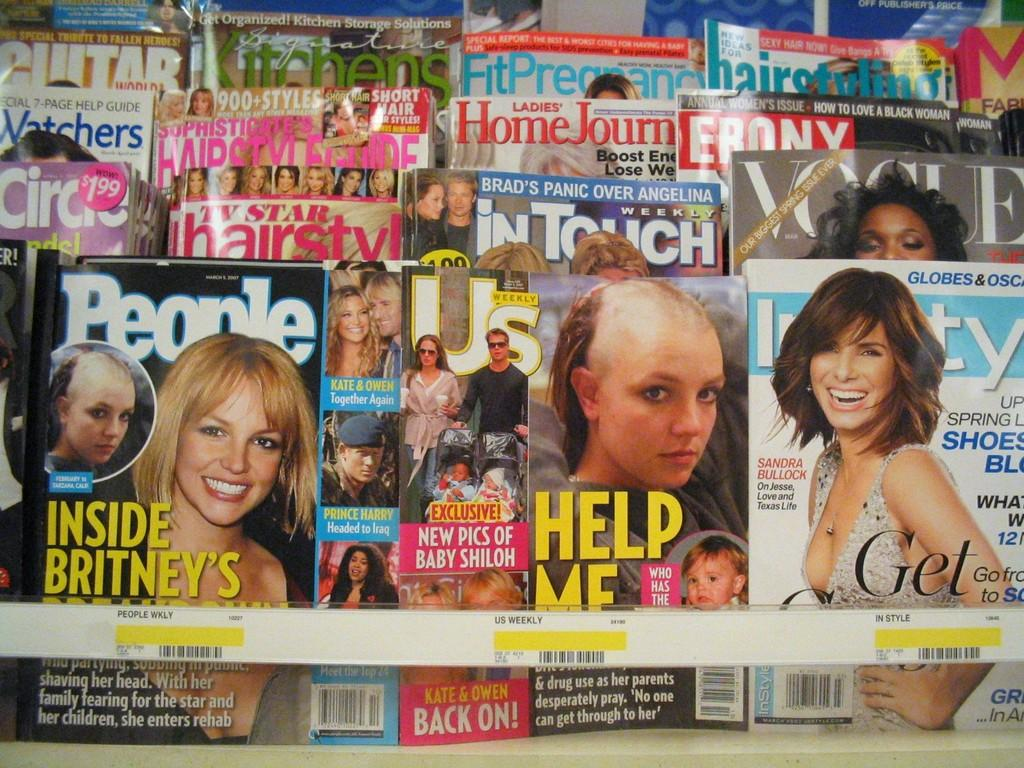What type of reading material is present in the image? There are magazines in the image. Where are the magazines located? The magazines are on a rack. What type of tank is visible in the image? There is no tank present in the image; it only features magazines on a rack. 